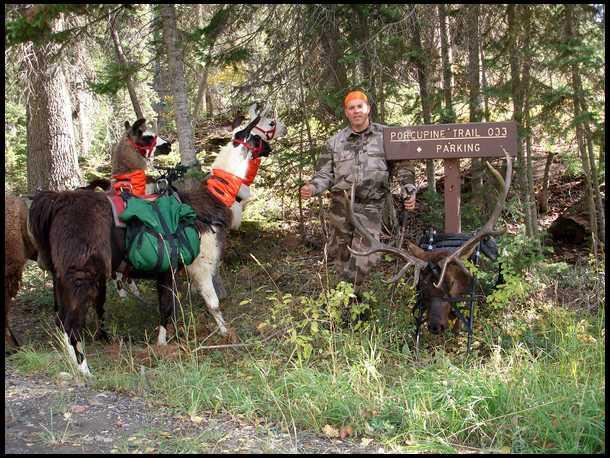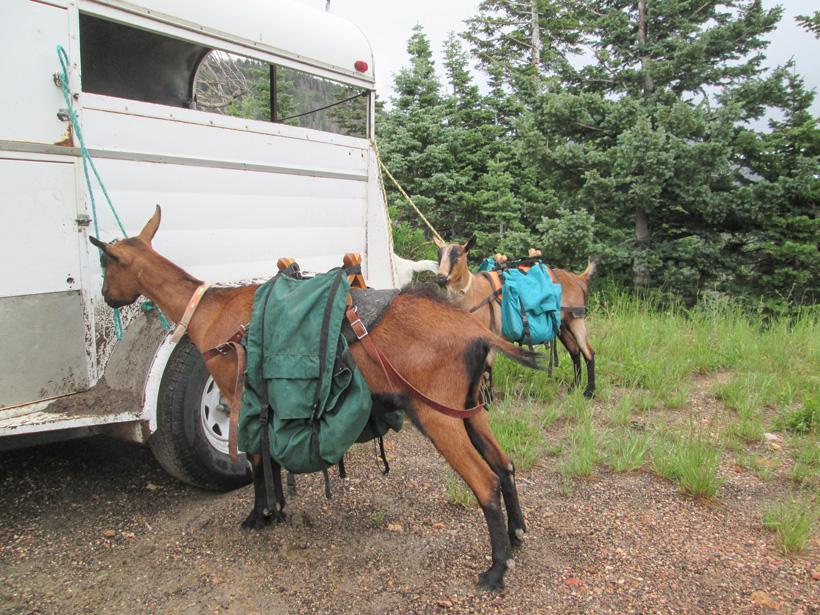The first image is the image on the left, the second image is the image on the right. Assess this claim about the two images: "In at least one image there is a hunter with deer horns and  two llames.". Correct or not? Answer yes or no. Yes. 